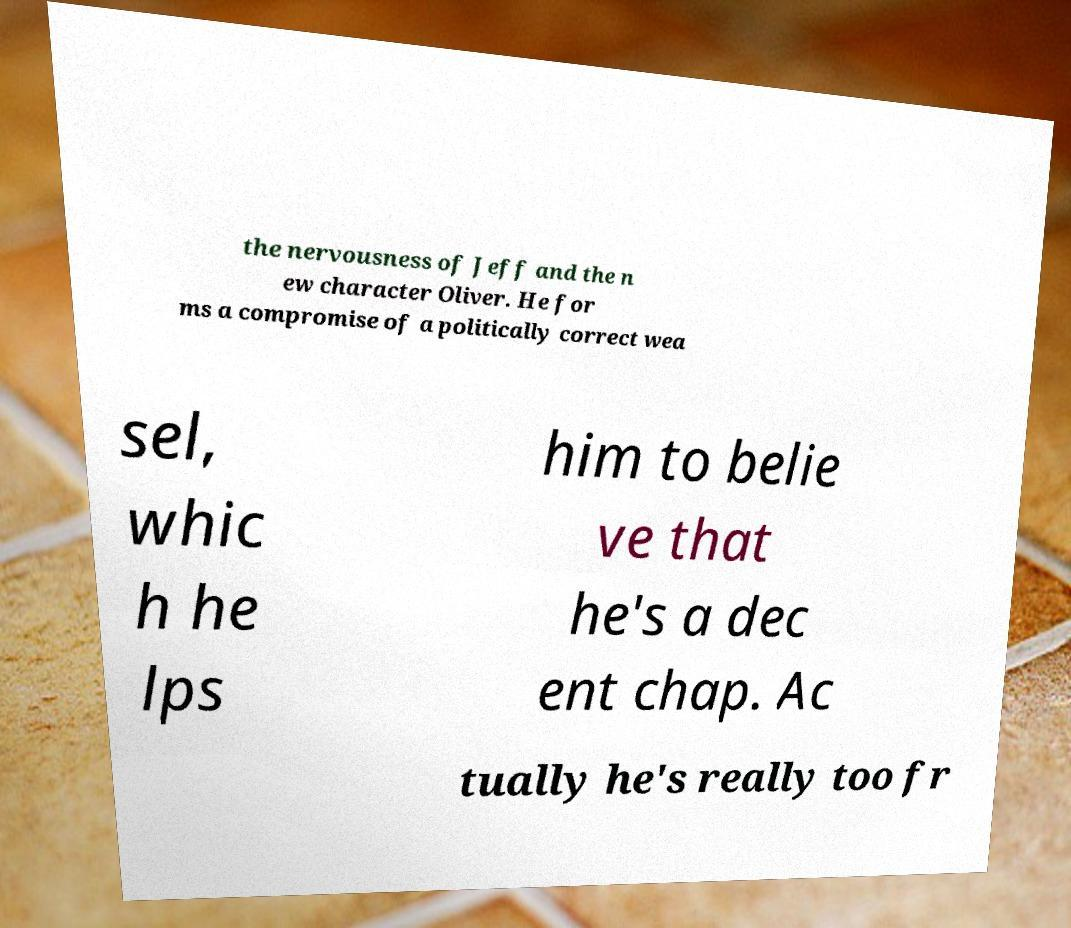There's text embedded in this image that I need extracted. Can you transcribe it verbatim? the nervousness of Jeff and the n ew character Oliver. He for ms a compromise of a politically correct wea sel, whic h he lps him to belie ve that he's a dec ent chap. Ac tually he's really too fr 